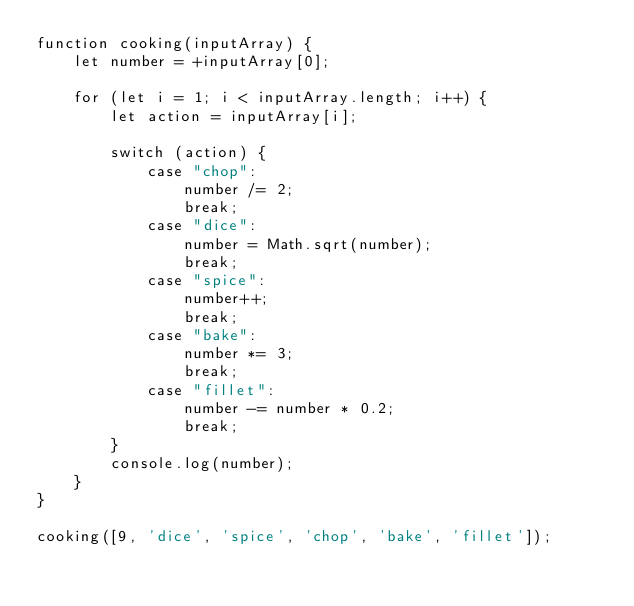Convert code to text. <code><loc_0><loc_0><loc_500><loc_500><_JavaScript_>function cooking(inputArray) {
    let number = +inputArray[0];

    for (let i = 1; i < inputArray.length; i++) {
        let action = inputArray[i];

        switch (action) {
            case "chop":
                number /= 2;
                break;
            case "dice":
                number = Math.sqrt(number);
                break;
            case "spice":
                number++;
                break;
            case "bake":
                number *= 3;
                break;
            case "fillet":
                number -= number * 0.2;
                break;
        }
        console.log(number);
    }
}

cooking([9, 'dice', 'spice', 'chop', 'bake', 'fillet']);</code> 